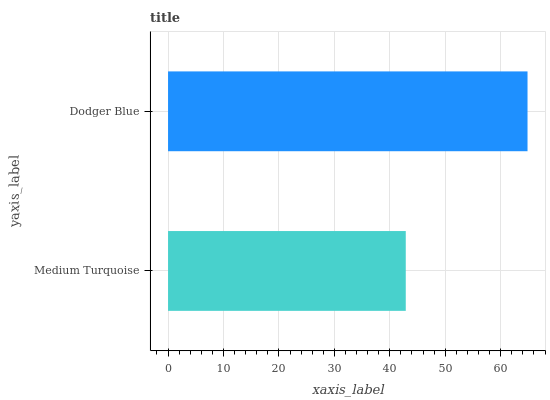Is Medium Turquoise the minimum?
Answer yes or no. Yes. Is Dodger Blue the maximum?
Answer yes or no. Yes. Is Dodger Blue the minimum?
Answer yes or no. No. Is Dodger Blue greater than Medium Turquoise?
Answer yes or no. Yes. Is Medium Turquoise less than Dodger Blue?
Answer yes or no. Yes. Is Medium Turquoise greater than Dodger Blue?
Answer yes or no. No. Is Dodger Blue less than Medium Turquoise?
Answer yes or no. No. Is Dodger Blue the high median?
Answer yes or no. Yes. Is Medium Turquoise the low median?
Answer yes or no. Yes. Is Medium Turquoise the high median?
Answer yes or no. No. Is Dodger Blue the low median?
Answer yes or no. No. 